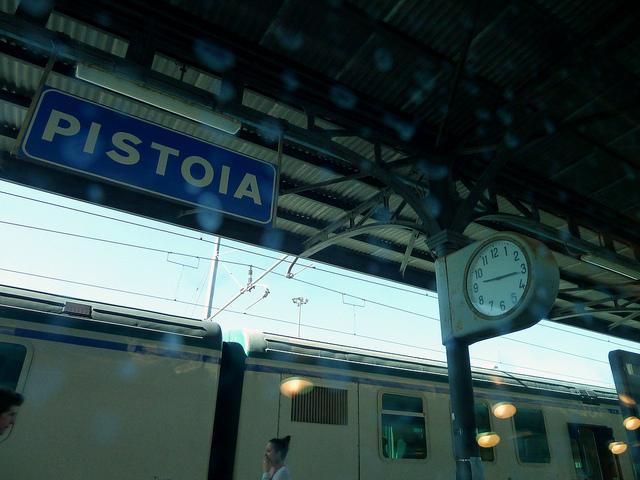What does the sign say?
Concise answer only. Pistoia. What color is the sign?
Quick response, please. Blue. What is the train stop?
Write a very short answer. Pistoia. 